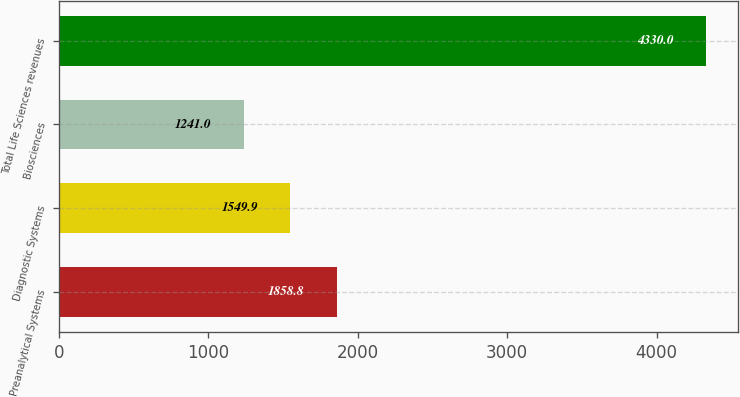Convert chart to OTSL. <chart><loc_0><loc_0><loc_500><loc_500><bar_chart><fcel>Preanalytical Systems<fcel>Diagnostic Systems<fcel>Biosciences<fcel>Total Life Sciences revenues<nl><fcel>1858.8<fcel>1549.9<fcel>1241<fcel>4330<nl></chart> 